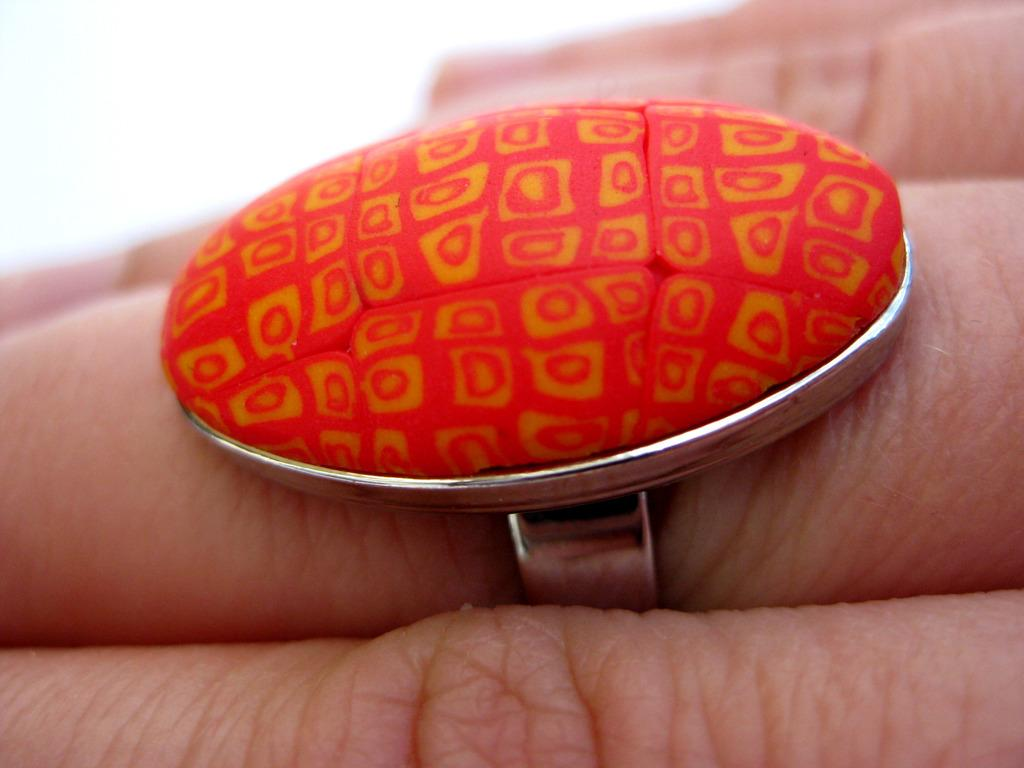What part of the human body is visible in the image? There is a human hand in the image. What is on the finger of the human hand? There is a ring on the finger of the human hand. What colors can be seen on the ring? The ring is silver, orange, and yellow in color. What color is the background of the image? The background of the image is white. What type of pickle is being stored in the pail in the image? There is no pickle or pail present in the image. What is the rod used for in the image? There is no rod present in the image. 